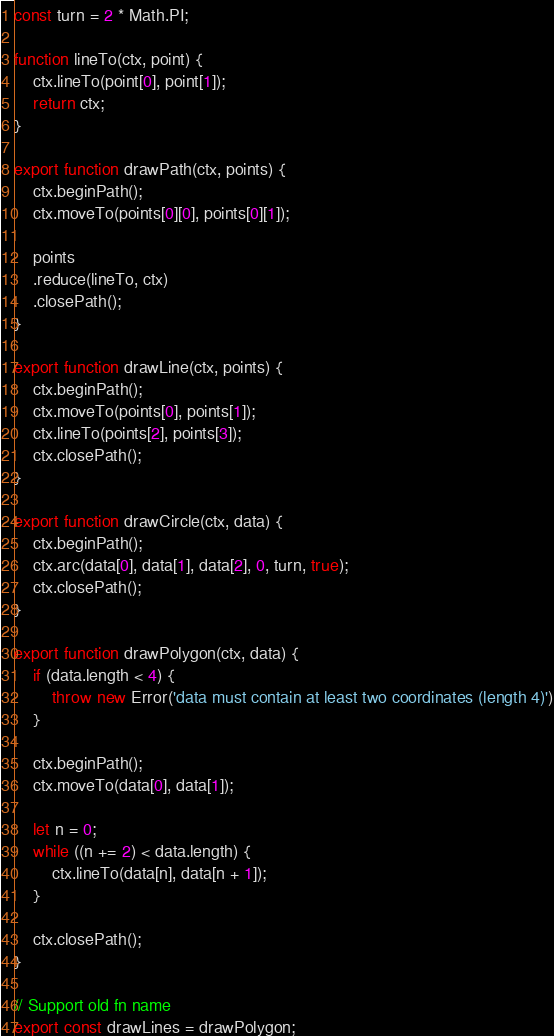Convert code to text. <code><loc_0><loc_0><loc_500><loc_500><_JavaScript_>
const turn = 2 * Math.PI;

function lineTo(ctx, point) {
    ctx.lineTo(point[0], point[1]);
    return ctx;
}

export function drawPath(ctx, points) {
    ctx.beginPath();
    ctx.moveTo(points[0][0], points[0][1]);

    points
    .reduce(lineTo, ctx)
    .closePath();
}

export function drawLine(ctx, points) {
    ctx.beginPath();
    ctx.moveTo(points[0], points[1]);
    ctx.lineTo(points[2], points[3]);
    ctx.closePath();
}

export function drawCircle(ctx, data) {
    ctx.beginPath();
    ctx.arc(data[0], data[1], data[2], 0, turn, true);
    ctx.closePath();
}

export function drawPolygon(ctx, data) {
    if (data.length < 4) {
        throw new Error('data must contain at least two coordinates (length 4)')
    }

    ctx.beginPath();
    ctx.moveTo(data[0], data[1]);

    let n = 0;
    while ((n += 2) < data.length) {
        ctx.lineTo(data[n], data[n + 1]);
    }

    ctx.closePath();
}

// Support old fn name
export const drawLines = drawPolygon;
</code> 